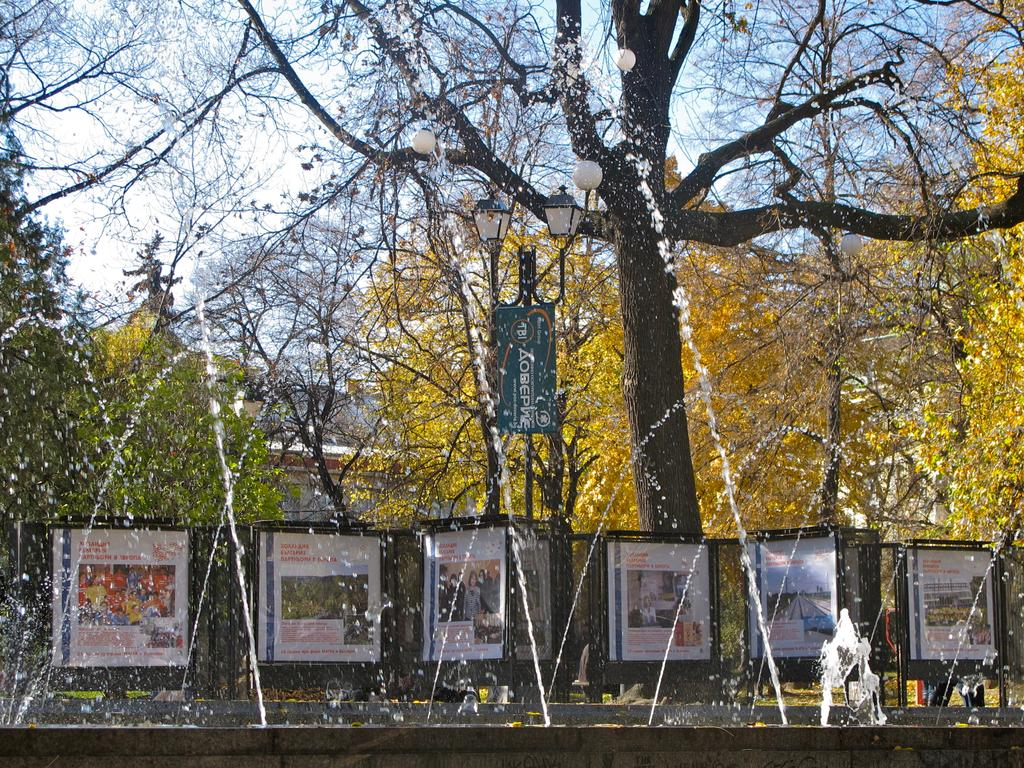What type of vegetation is present in the image? There are trees in the image. What type of decorations or advertisements can be seen in the image? There are posters in the image. What type of water feature is present in the image? There are fountains in the image. What type of structures are present in the image? There are poles in the image. What type of illumination is present in the image? There are lights in the image. What is visible in the background of the image? The sky is visible in the image. How many pizzas are being served at the event in the image? There is no event or pizzas present in the image. In which direction is the pot facing in the image? There is no pot present in the image. 